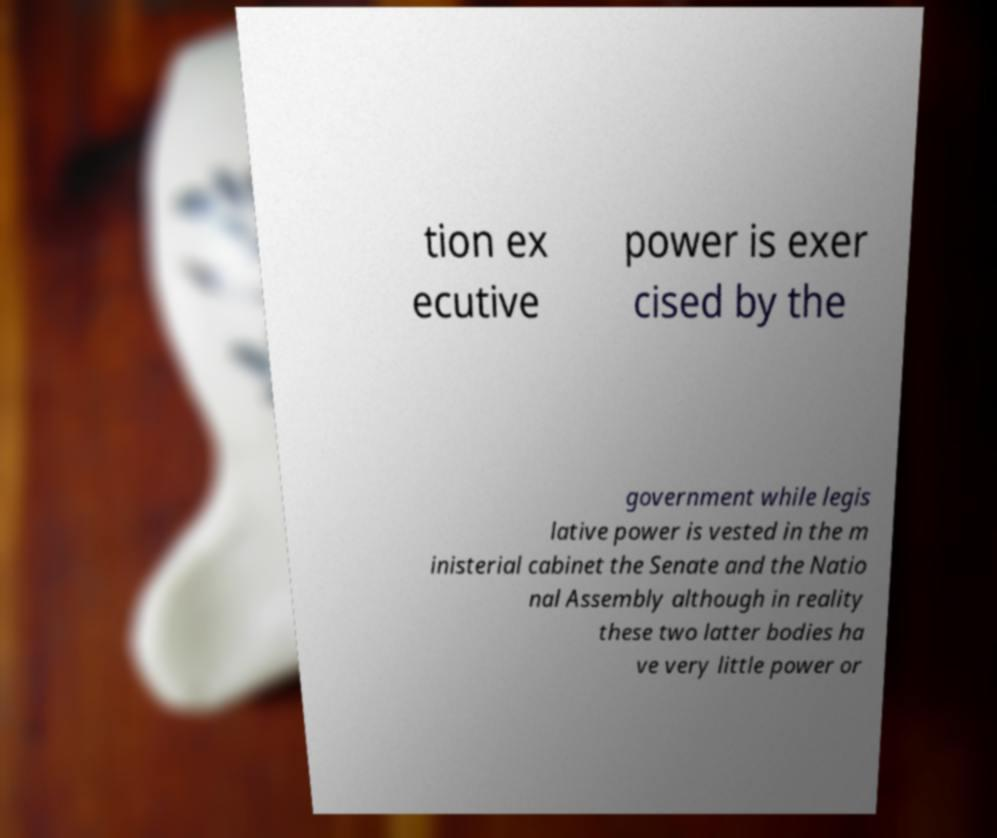Please identify and transcribe the text found in this image. tion ex ecutive power is exer cised by the government while legis lative power is vested in the m inisterial cabinet the Senate and the Natio nal Assembly although in reality these two latter bodies ha ve very little power or 